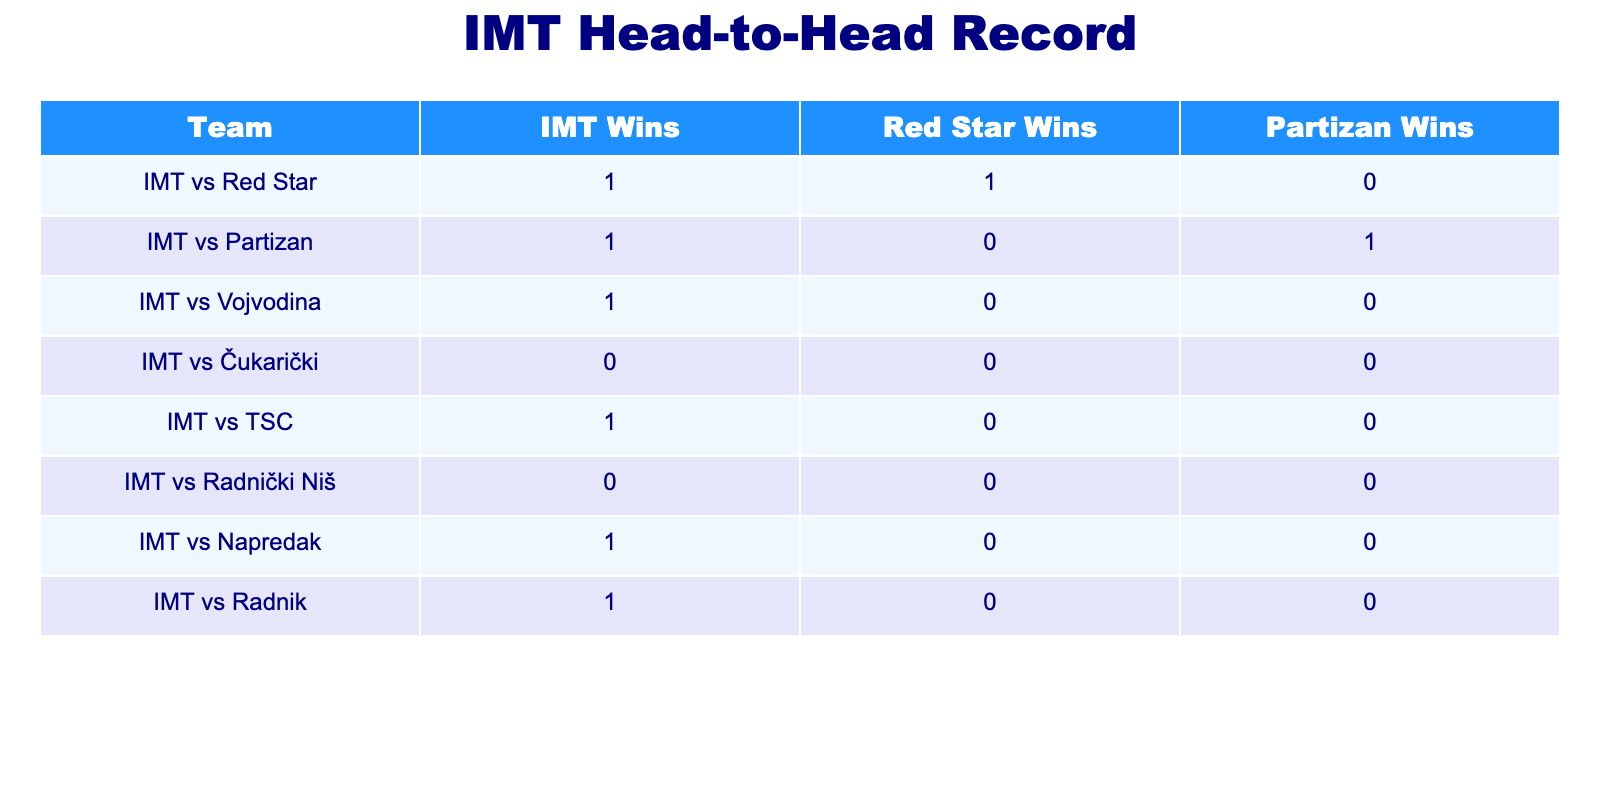What is the total number of wins IMT has against Red Star? From the table, IMT has 1 win against Red Star, as shown in the row for "IMT vs Red Star" in the "IMT Wins" column.
Answer: 1 How many matches did IMT win against Partizan? According to the table, IMT has 1 win against Partizan, found in the row for "IMT vs Partizan."
Answer: 1 Did IMT ever draw a match against any of its rivals? In the table, there are no instances of draws between IMT and any of its rivals, as all games either show wins for IMT or the rival teams.
Answer: No Which team has the highest number of wins against IMT? Analyzing the rows for each rival team, Partizan has 1 win against IMT, while Red Star also has 1 win, but no other team has any wins. Therefore, Red Star and Partizan are tied for the most wins.
Answer: Red Star and Partizan What is the combined total of wins by IMT across all listed rivals? To find this, we sum the "IMT Wins" column values: 1 (vs Red Star) + 1 (vs Partizan) + 1 (vs Vojvodina) + 0 (vs Čukarički) + 1 (vs TSC) + 0 (vs Radnički Niš) + 1 (vs Napredak) + 1 (vs Radnik) = 5.
Answer: 5 Is it true that IMT has never lost to Vojvodina? Referring to the table, IMT has 1 win against Vojvodina and 0 losses recorded in the "Vojvodina Wins" column, indicating that IMT has not lost to them.
Answer: Yes What percentage of IMT's wins are against rival teams compared to their total matches listed? The total matches listed are 8 (counting all rows), and IMT has 5 wins. To find the percentage: (5 wins / 8 total matches) * 100 = 62.5%.
Answer: 62.5% If we consider only the losses by IMT, how many total losses can we identify from the table? The table shows no entries in the "IMT Wins" column for losses, meaning all games are either wins for IMT or wins for the opposing teams. Hence, we count the number of wins for rivals (Red Star: 1, Partizan: 1), resulting in 2.
Answer: 2 